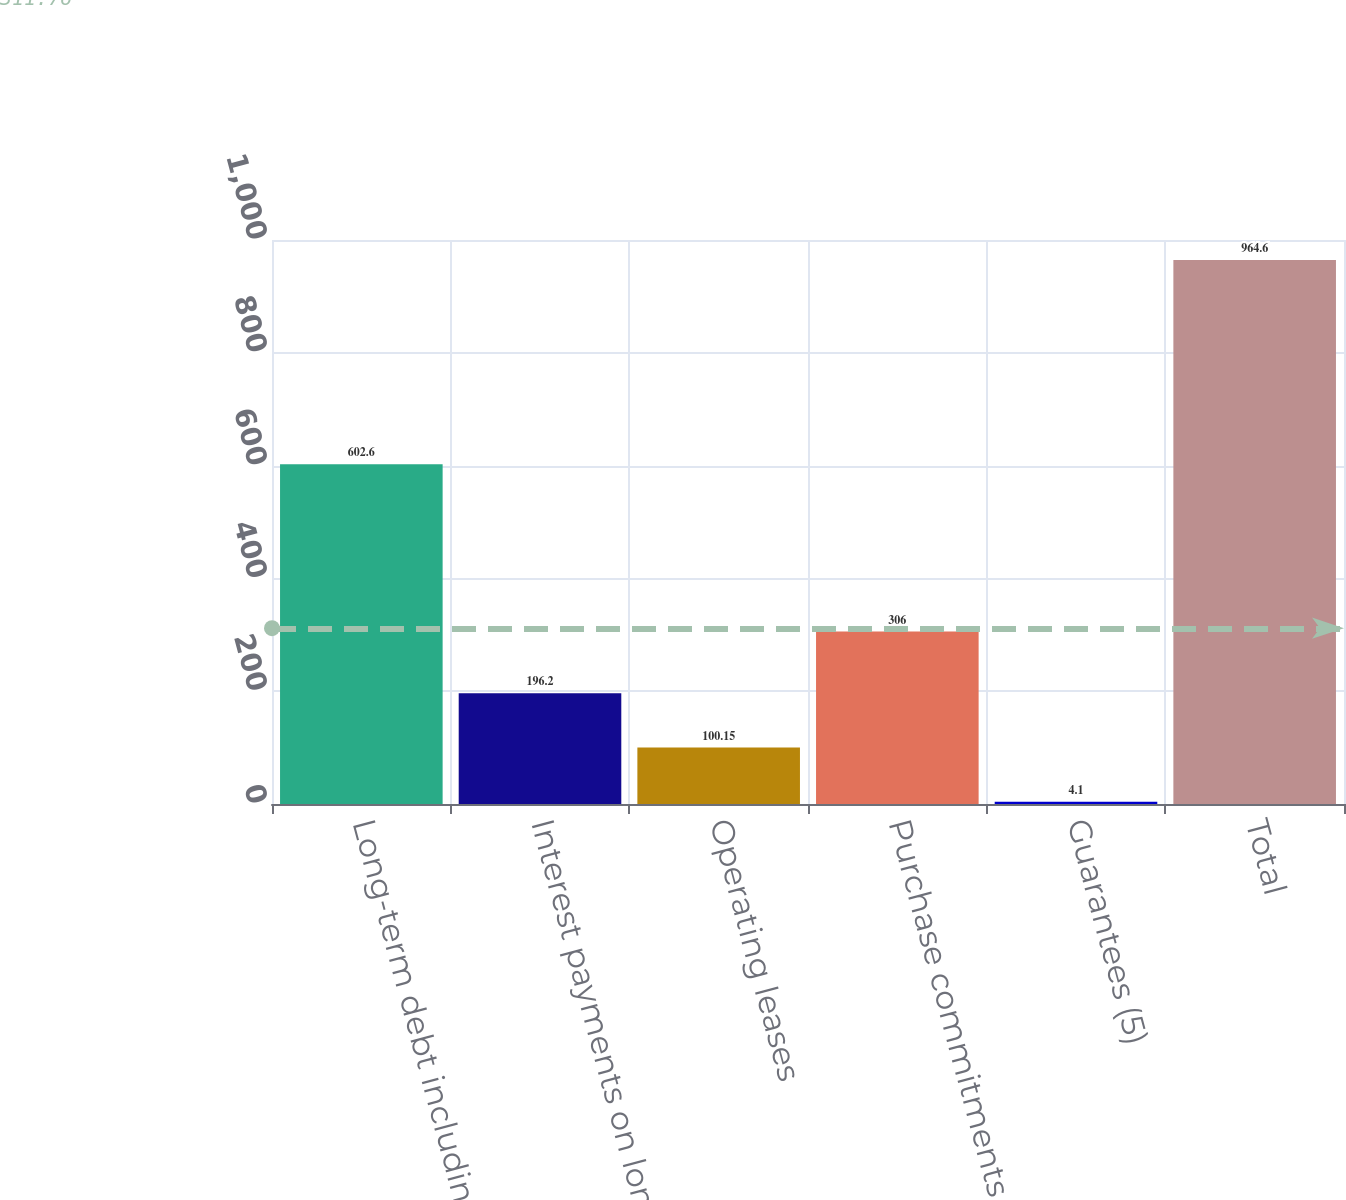<chart> <loc_0><loc_0><loc_500><loc_500><bar_chart><fcel>Long-term debt including<fcel>Interest payments on long-term<fcel>Operating leases<fcel>Purchase commitments (2)<fcel>Guarantees (5)<fcel>Total<nl><fcel>602.6<fcel>196.2<fcel>100.15<fcel>306<fcel>4.1<fcel>964.6<nl></chart> 